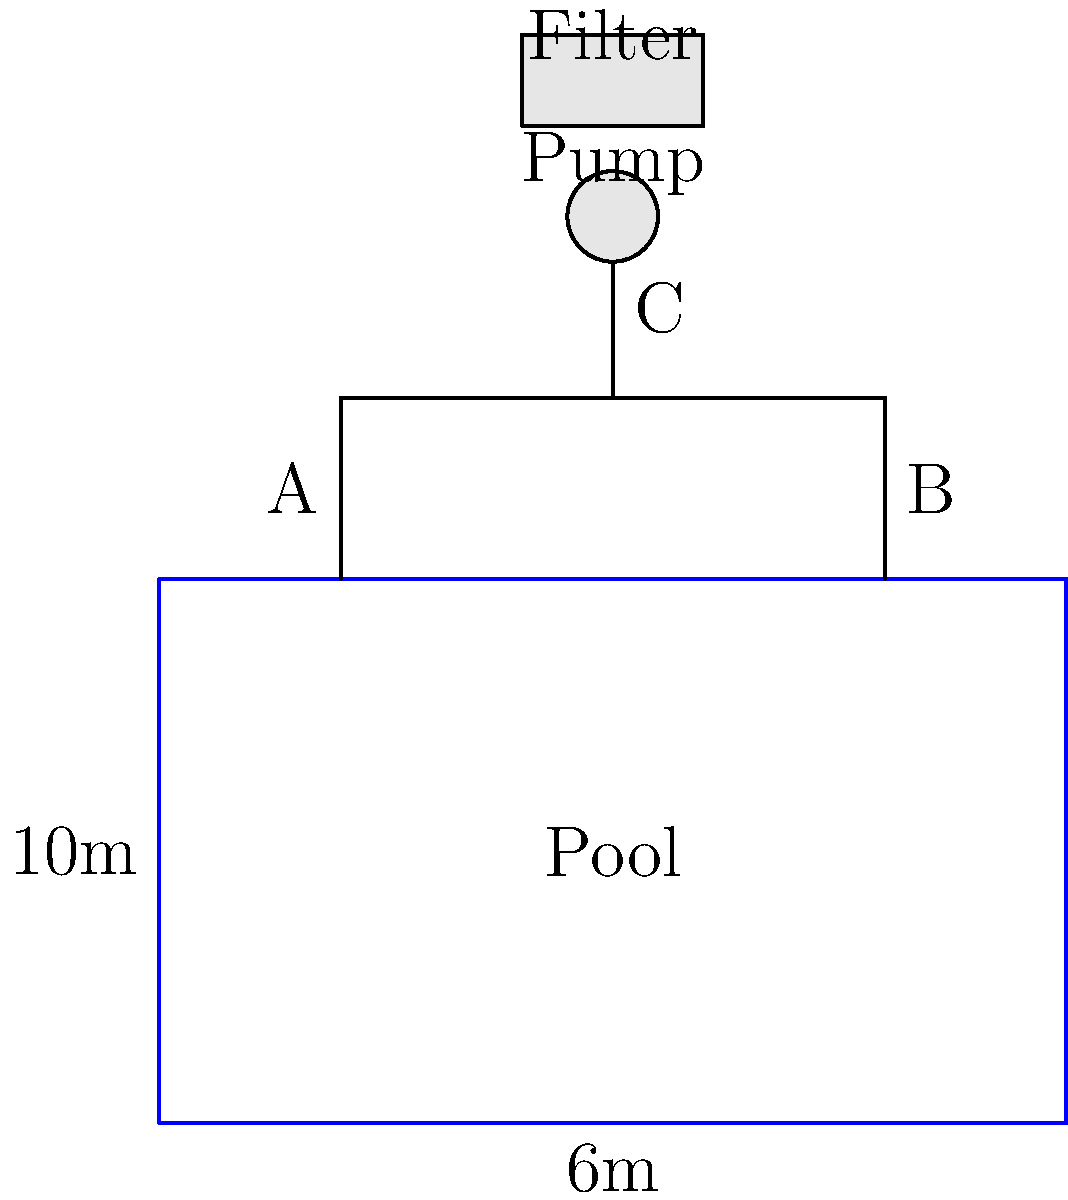As a mother concerned about your child's safety in the local swimming pool, you've been asked to review the filtration system design. The diagram shows a simplified pipe network for the pool's filtration system. If the flow rate from point A to B is 100 liters per minute, and the flow rate from B to C is 75 liters per minute, what is the flow rate (in liters per minute) from point C to the filter? To solve this problem, we'll use the concept of conservation of mass in fluid dynamics. Here's a step-by-step explanation:

1. Identify the known flow rates:
   - Flow rate from A to B: 100 liters/minute
   - Flow rate from B to C: 75 liters/minute

2. Apply the principle of conservation of mass:
   - At point B, the incoming flow (from A) must equal the sum of outgoing flows (to C and the pool)
   - Let's call the flow rate returning to the pool at point B as $x$ liters/minute

3. Set up an equation:
   $100 = 75 + x$

4. Solve for $x$:
   $x = 100 - 75 = 25$ liters/minute

5. Determine the flow rate from C to the filter:
   - The flow entering C (75 L/min) must equal the flow leaving C to the filter
   - Therefore, the flow rate from C to the filter is 75 liters/minute

This analysis ensures that all the water pumped from the pool is filtered and returned, maintaining proper circulation and cleanliness for your child's safety.
Answer: 75 liters/minute 